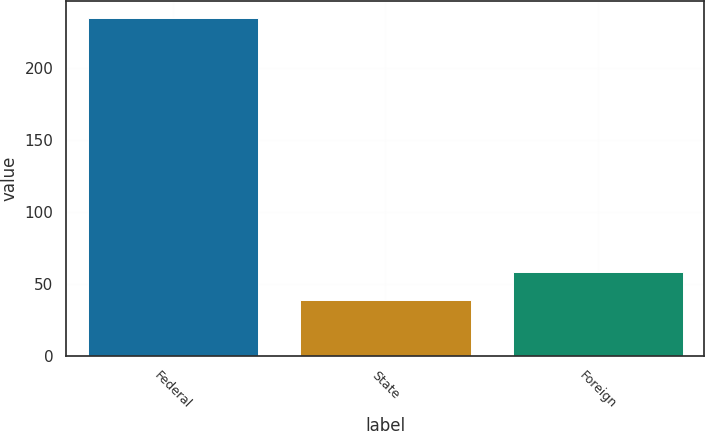<chart> <loc_0><loc_0><loc_500><loc_500><bar_chart><fcel>Federal<fcel>State<fcel>Foreign<nl><fcel>235.1<fcel>38.6<fcel>58.25<nl></chart> 